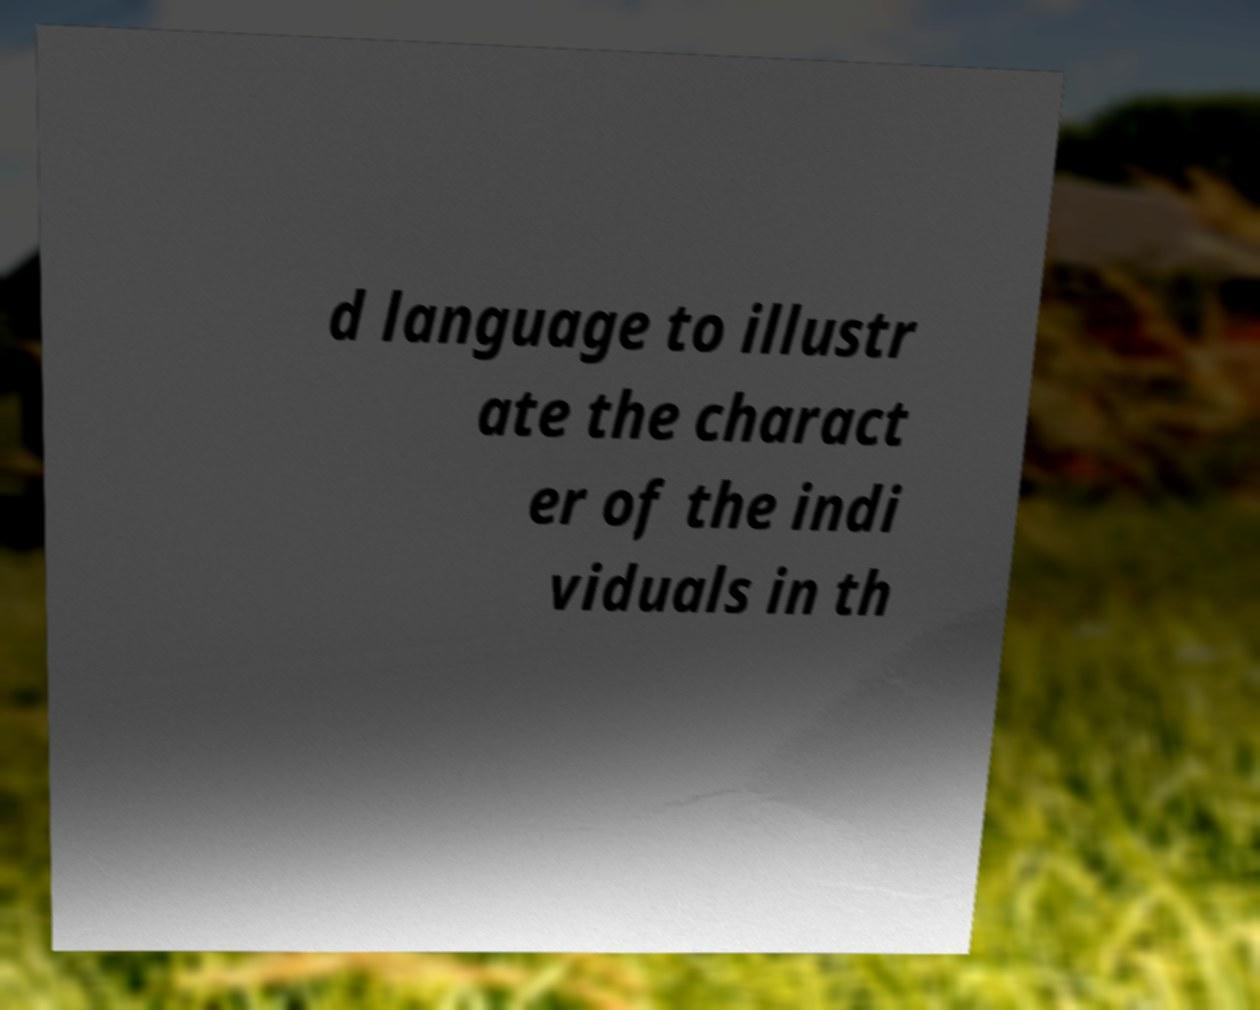I need the written content from this picture converted into text. Can you do that? d language to illustr ate the charact er of the indi viduals in th 